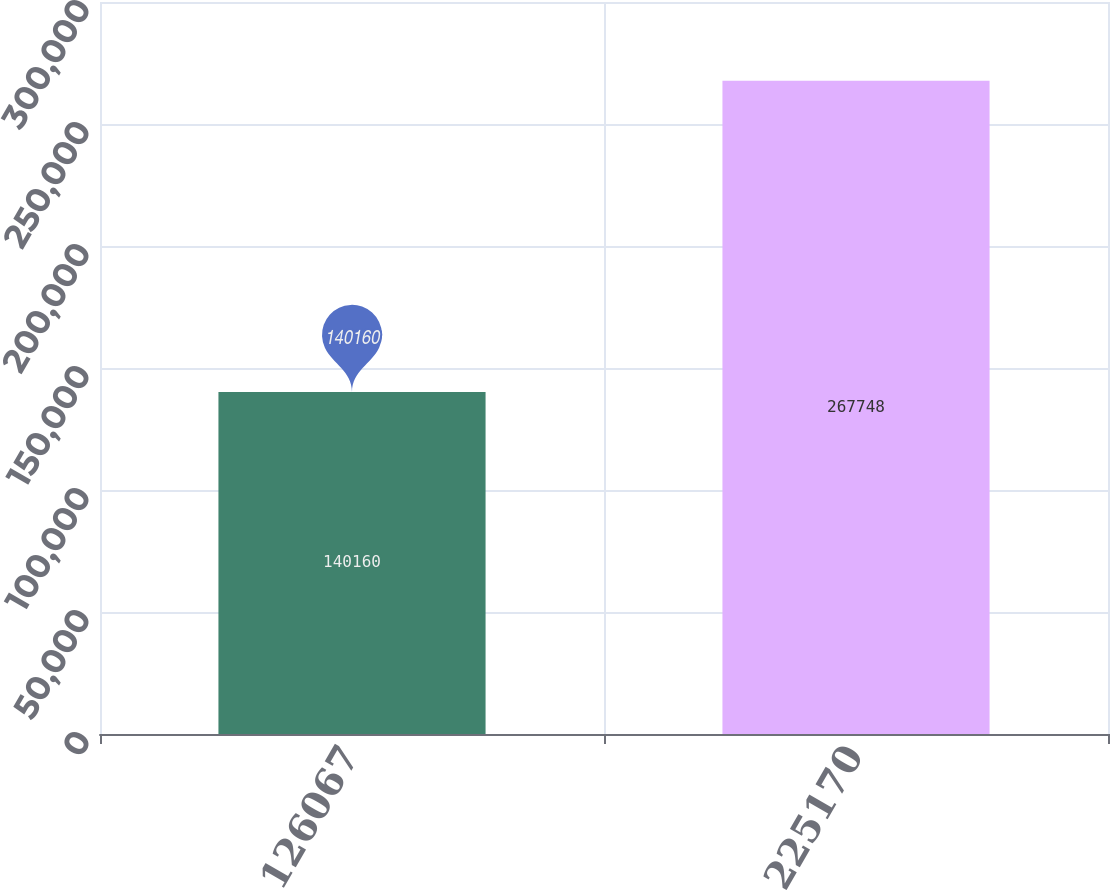Convert chart. <chart><loc_0><loc_0><loc_500><loc_500><bar_chart><fcel>126067<fcel>225170<nl><fcel>140160<fcel>267748<nl></chart> 